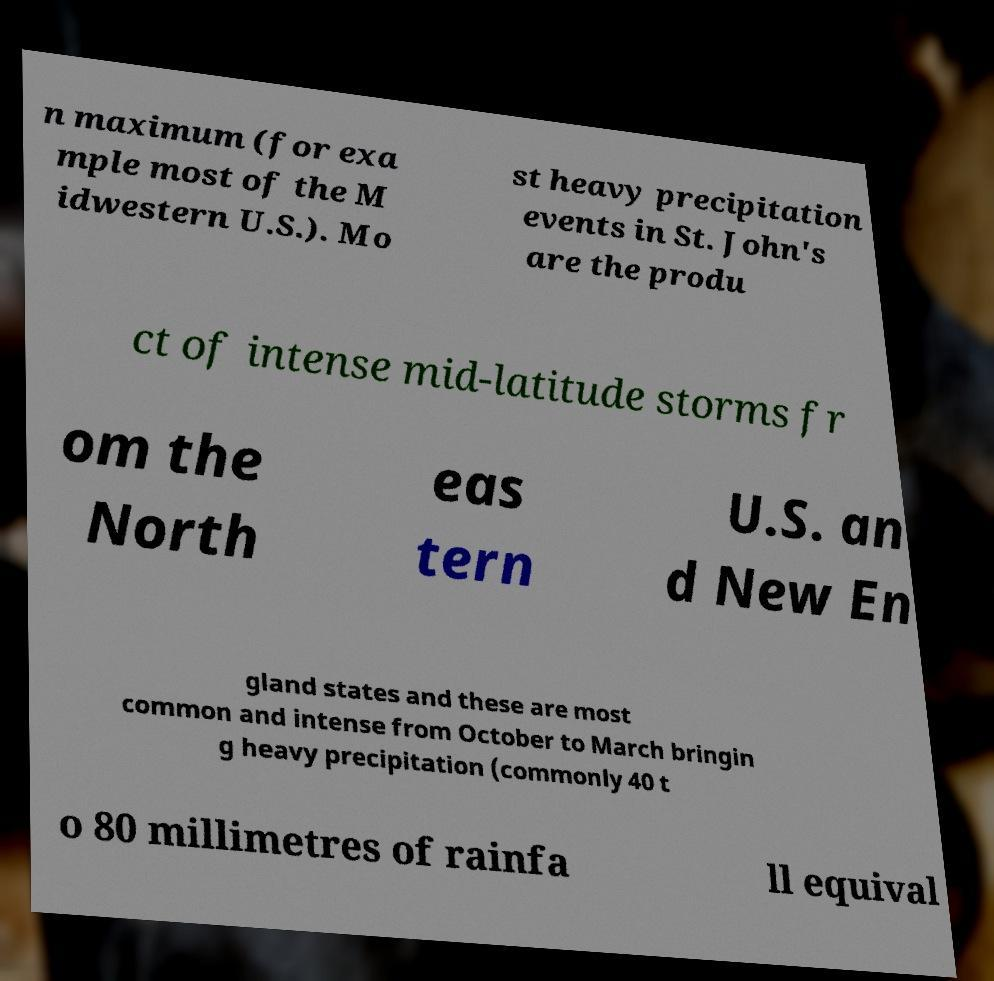What messages or text are displayed in this image? I need them in a readable, typed format. n maximum (for exa mple most of the M idwestern U.S.). Mo st heavy precipitation events in St. John's are the produ ct of intense mid-latitude storms fr om the North eas tern U.S. an d New En gland states and these are most common and intense from October to March bringin g heavy precipitation (commonly 40 t o 80 millimetres of rainfa ll equival 